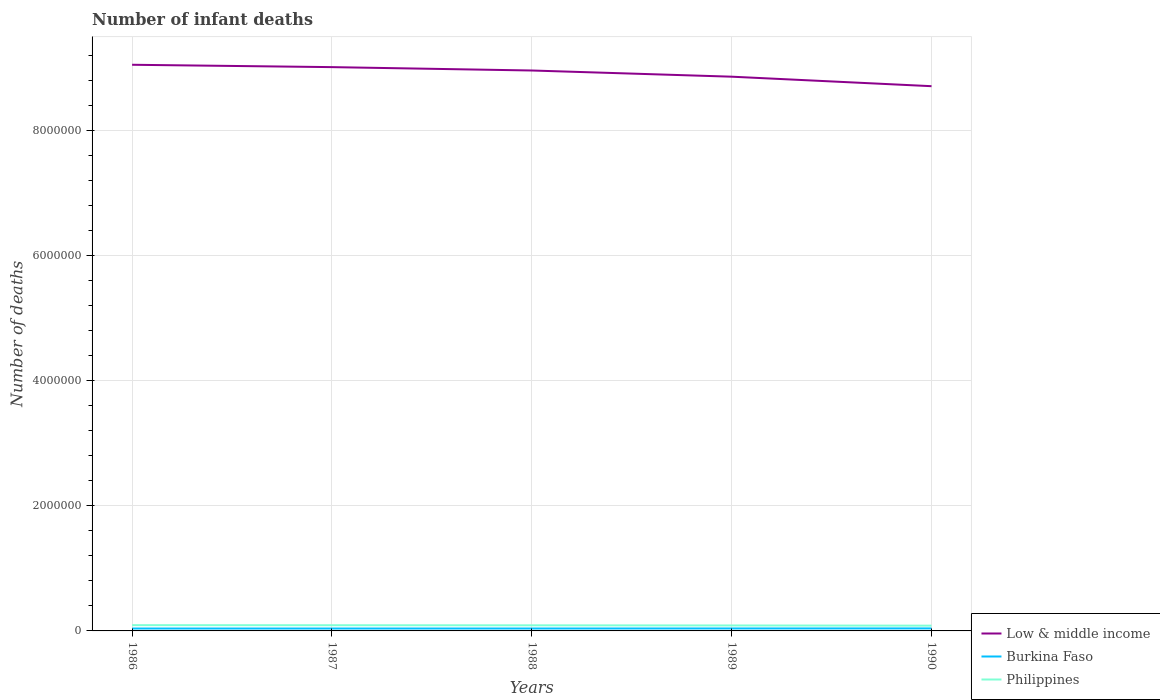How many different coloured lines are there?
Provide a succinct answer. 3. Across all years, what is the maximum number of infant deaths in Burkina Faso?
Make the answer very short. 3.85e+04. What is the total number of infant deaths in Low & middle income in the graph?
Provide a short and direct response. 3.42e+05. What is the difference between the highest and the second highest number of infant deaths in Burkina Faso?
Give a very brief answer. 1697. How many lines are there?
Provide a succinct answer. 3. What is the difference between two consecutive major ticks on the Y-axis?
Your answer should be very brief. 2.00e+06. How many legend labels are there?
Offer a terse response. 3. What is the title of the graph?
Offer a terse response. Number of infant deaths. What is the label or title of the Y-axis?
Your answer should be compact. Number of deaths. What is the Number of deaths in Low & middle income in 1986?
Make the answer very short. 9.05e+06. What is the Number of deaths in Burkina Faso in 1986?
Your response must be concise. 3.85e+04. What is the Number of deaths of Philippines in 1986?
Give a very brief answer. 9.21e+04. What is the Number of deaths in Low & middle income in 1987?
Provide a succinct answer. 9.01e+06. What is the Number of deaths of Burkina Faso in 1987?
Keep it short and to the point. 3.86e+04. What is the Number of deaths of Philippines in 1987?
Offer a terse response. 9.10e+04. What is the Number of deaths in Low & middle income in 1988?
Your response must be concise. 8.96e+06. What is the Number of deaths in Burkina Faso in 1988?
Offer a very short reply. 3.88e+04. What is the Number of deaths in Philippines in 1988?
Offer a very short reply. 8.93e+04. What is the Number of deaths of Low & middle income in 1989?
Your response must be concise. 8.86e+06. What is the Number of deaths in Burkina Faso in 1989?
Provide a short and direct response. 3.93e+04. What is the Number of deaths in Philippines in 1989?
Your response must be concise. 8.70e+04. What is the Number of deaths in Low & middle income in 1990?
Give a very brief answer. 8.71e+06. What is the Number of deaths in Burkina Faso in 1990?
Keep it short and to the point. 4.02e+04. What is the Number of deaths in Philippines in 1990?
Your answer should be compact. 8.41e+04. Across all years, what is the maximum Number of deaths of Low & middle income?
Offer a terse response. 9.05e+06. Across all years, what is the maximum Number of deaths in Burkina Faso?
Offer a very short reply. 4.02e+04. Across all years, what is the maximum Number of deaths in Philippines?
Your response must be concise. 9.21e+04. Across all years, what is the minimum Number of deaths of Low & middle income?
Provide a succinct answer. 8.71e+06. Across all years, what is the minimum Number of deaths in Burkina Faso?
Keep it short and to the point. 3.85e+04. Across all years, what is the minimum Number of deaths of Philippines?
Give a very brief answer. 8.41e+04. What is the total Number of deaths in Low & middle income in the graph?
Your response must be concise. 4.46e+07. What is the total Number of deaths of Burkina Faso in the graph?
Provide a short and direct response. 1.95e+05. What is the total Number of deaths in Philippines in the graph?
Offer a very short reply. 4.44e+05. What is the difference between the Number of deaths in Low & middle income in 1986 and that in 1987?
Offer a very short reply. 3.79e+04. What is the difference between the Number of deaths of Burkina Faso in 1986 and that in 1987?
Make the answer very short. -58. What is the difference between the Number of deaths in Philippines in 1986 and that in 1987?
Your answer should be compact. 1083. What is the difference between the Number of deaths of Low & middle income in 1986 and that in 1988?
Your answer should be very brief. 9.18e+04. What is the difference between the Number of deaths of Burkina Faso in 1986 and that in 1988?
Provide a succinct answer. -287. What is the difference between the Number of deaths of Philippines in 1986 and that in 1988?
Provide a short and direct response. 2729. What is the difference between the Number of deaths in Low & middle income in 1986 and that in 1989?
Make the answer very short. 1.91e+05. What is the difference between the Number of deaths in Burkina Faso in 1986 and that in 1989?
Give a very brief answer. -838. What is the difference between the Number of deaths of Philippines in 1986 and that in 1989?
Offer a terse response. 5028. What is the difference between the Number of deaths of Low & middle income in 1986 and that in 1990?
Provide a short and direct response. 3.42e+05. What is the difference between the Number of deaths of Burkina Faso in 1986 and that in 1990?
Give a very brief answer. -1697. What is the difference between the Number of deaths of Philippines in 1986 and that in 1990?
Ensure brevity in your answer.  7913. What is the difference between the Number of deaths of Low & middle income in 1987 and that in 1988?
Make the answer very short. 5.39e+04. What is the difference between the Number of deaths of Burkina Faso in 1987 and that in 1988?
Offer a very short reply. -229. What is the difference between the Number of deaths in Philippines in 1987 and that in 1988?
Provide a succinct answer. 1646. What is the difference between the Number of deaths in Low & middle income in 1987 and that in 1989?
Your answer should be very brief. 1.53e+05. What is the difference between the Number of deaths in Burkina Faso in 1987 and that in 1989?
Offer a very short reply. -780. What is the difference between the Number of deaths of Philippines in 1987 and that in 1989?
Your response must be concise. 3945. What is the difference between the Number of deaths of Low & middle income in 1987 and that in 1990?
Your answer should be very brief. 3.04e+05. What is the difference between the Number of deaths in Burkina Faso in 1987 and that in 1990?
Provide a succinct answer. -1639. What is the difference between the Number of deaths of Philippines in 1987 and that in 1990?
Ensure brevity in your answer.  6830. What is the difference between the Number of deaths of Low & middle income in 1988 and that in 1989?
Provide a succinct answer. 9.88e+04. What is the difference between the Number of deaths in Burkina Faso in 1988 and that in 1989?
Your response must be concise. -551. What is the difference between the Number of deaths in Philippines in 1988 and that in 1989?
Offer a very short reply. 2299. What is the difference between the Number of deaths of Low & middle income in 1988 and that in 1990?
Your answer should be compact. 2.51e+05. What is the difference between the Number of deaths in Burkina Faso in 1988 and that in 1990?
Provide a short and direct response. -1410. What is the difference between the Number of deaths in Philippines in 1988 and that in 1990?
Offer a very short reply. 5184. What is the difference between the Number of deaths of Low & middle income in 1989 and that in 1990?
Keep it short and to the point. 1.52e+05. What is the difference between the Number of deaths of Burkina Faso in 1989 and that in 1990?
Make the answer very short. -859. What is the difference between the Number of deaths of Philippines in 1989 and that in 1990?
Keep it short and to the point. 2885. What is the difference between the Number of deaths of Low & middle income in 1986 and the Number of deaths of Burkina Faso in 1987?
Your answer should be compact. 9.01e+06. What is the difference between the Number of deaths in Low & middle income in 1986 and the Number of deaths in Philippines in 1987?
Provide a short and direct response. 8.96e+06. What is the difference between the Number of deaths in Burkina Faso in 1986 and the Number of deaths in Philippines in 1987?
Ensure brevity in your answer.  -5.25e+04. What is the difference between the Number of deaths of Low & middle income in 1986 and the Number of deaths of Burkina Faso in 1988?
Your response must be concise. 9.01e+06. What is the difference between the Number of deaths of Low & middle income in 1986 and the Number of deaths of Philippines in 1988?
Provide a succinct answer. 8.96e+06. What is the difference between the Number of deaths in Burkina Faso in 1986 and the Number of deaths in Philippines in 1988?
Provide a succinct answer. -5.08e+04. What is the difference between the Number of deaths of Low & middle income in 1986 and the Number of deaths of Burkina Faso in 1989?
Make the answer very short. 9.01e+06. What is the difference between the Number of deaths of Low & middle income in 1986 and the Number of deaths of Philippines in 1989?
Make the answer very short. 8.96e+06. What is the difference between the Number of deaths of Burkina Faso in 1986 and the Number of deaths of Philippines in 1989?
Give a very brief answer. -4.85e+04. What is the difference between the Number of deaths of Low & middle income in 1986 and the Number of deaths of Burkina Faso in 1990?
Provide a short and direct response. 9.01e+06. What is the difference between the Number of deaths in Low & middle income in 1986 and the Number of deaths in Philippines in 1990?
Provide a succinct answer. 8.96e+06. What is the difference between the Number of deaths in Burkina Faso in 1986 and the Number of deaths in Philippines in 1990?
Offer a terse response. -4.56e+04. What is the difference between the Number of deaths in Low & middle income in 1987 and the Number of deaths in Burkina Faso in 1988?
Your answer should be compact. 8.97e+06. What is the difference between the Number of deaths in Low & middle income in 1987 and the Number of deaths in Philippines in 1988?
Your answer should be compact. 8.92e+06. What is the difference between the Number of deaths in Burkina Faso in 1987 and the Number of deaths in Philippines in 1988?
Give a very brief answer. -5.08e+04. What is the difference between the Number of deaths in Low & middle income in 1987 and the Number of deaths in Burkina Faso in 1989?
Your answer should be compact. 8.97e+06. What is the difference between the Number of deaths of Low & middle income in 1987 and the Number of deaths of Philippines in 1989?
Your answer should be very brief. 8.92e+06. What is the difference between the Number of deaths of Burkina Faso in 1987 and the Number of deaths of Philippines in 1989?
Provide a succinct answer. -4.85e+04. What is the difference between the Number of deaths of Low & middle income in 1987 and the Number of deaths of Burkina Faso in 1990?
Your answer should be very brief. 8.97e+06. What is the difference between the Number of deaths of Low & middle income in 1987 and the Number of deaths of Philippines in 1990?
Offer a very short reply. 8.93e+06. What is the difference between the Number of deaths in Burkina Faso in 1987 and the Number of deaths in Philippines in 1990?
Offer a terse response. -4.56e+04. What is the difference between the Number of deaths in Low & middle income in 1988 and the Number of deaths in Burkina Faso in 1989?
Keep it short and to the point. 8.92e+06. What is the difference between the Number of deaths of Low & middle income in 1988 and the Number of deaths of Philippines in 1989?
Ensure brevity in your answer.  8.87e+06. What is the difference between the Number of deaths of Burkina Faso in 1988 and the Number of deaths of Philippines in 1989?
Give a very brief answer. -4.82e+04. What is the difference between the Number of deaths in Low & middle income in 1988 and the Number of deaths in Burkina Faso in 1990?
Offer a terse response. 8.92e+06. What is the difference between the Number of deaths in Low & middle income in 1988 and the Number of deaths in Philippines in 1990?
Provide a succinct answer. 8.87e+06. What is the difference between the Number of deaths in Burkina Faso in 1988 and the Number of deaths in Philippines in 1990?
Your response must be concise. -4.53e+04. What is the difference between the Number of deaths in Low & middle income in 1989 and the Number of deaths in Burkina Faso in 1990?
Offer a very short reply. 8.82e+06. What is the difference between the Number of deaths in Low & middle income in 1989 and the Number of deaths in Philippines in 1990?
Offer a very short reply. 8.77e+06. What is the difference between the Number of deaths of Burkina Faso in 1989 and the Number of deaths of Philippines in 1990?
Make the answer very short. -4.48e+04. What is the average Number of deaths in Low & middle income per year?
Your answer should be very brief. 8.92e+06. What is the average Number of deaths in Burkina Faso per year?
Give a very brief answer. 3.91e+04. What is the average Number of deaths of Philippines per year?
Ensure brevity in your answer.  8.87e+04. In the year 1986, what is the difference between the Number of deaths of Low & middle income and Number of deaths of Burkina Faso?
Keep it short and to the point. 9.01e+06. In the year 1986, what is the difference between the Number of deaths of Low & middle income and Number of deaths of Philippines?
Give a very brief answer. 8.96e+06. In the year 1986, what is the difference between the Number of deaths of Burkina Faso and Number of deaths of Philippines?
Your answer should be very brief. -5.35e+04. In the year 1987, what is the difference between the Number of deaths of Low & middle income and Number of deaths of Burkina Faso?
Your answer should be compact. 8.97e+06. In the year 1987, what is the difference between the Number of deaths in Low & middle income and Number of deaths in Philippines?
Your answer should be compact. 8.92e+06. In the year 1987, what is the difference between the Number of deaths in Burkina Faso and Number of deaths in Philippines?
Keep it short and to the point. -5.24e+04. In the year 1988, what is the difference between the Number of deaths of Low & middle income and Number of deaths of Burkina Faso?
Ensure brevity in your answer.  8.92e+06. In the year 1988, what is the difference between the Number of deaths of Low & middle income and Number of deaths of Philippines?
Your answer should be compact. 8.87e+06. In the year 1988, what is the difference between the Number of deaths in Burkina Faso and Number of deaths in Philippines?
Provide a succinct answer. -5.05e+04. In the year 1989, what is the difference between the Number of deaths in Low & middle income and Number of deaths in Burkina Faso?
Ensure brevity in your answer.  8.82e+06. In the year 1989, what is the difference between the Number of deaths in Low & middle income and Number of deaths in Philippines?
Offer a very short reply. 8.77e+06. In the year 1989, what is the difference between the Number of deaths in Burkina Faso and Number of deaths in Philippines?
Your answer should be very brief. -4.77e+04. In the year 1990, what is the difference between the Number of deaths in Low & middle income and Number of deaths in Burkina Faso?
Provide a succinct answer. 8.67e+06. In the year 1990, what is the difference between the Number of deaths in Low & middle income and Number of deaths in Philippines?
Provide a succinct answer. 8.62e+06. In the year 1990, what is the difference between the Number of deaths in Burkina Faso and Number of deaths in Philippines?
Your answer should be very brief. -4.39e+04. What is the ratio of the Number of deaths in Burkina Faso in 1986 to that in 1987?
Offer a very short reply. 1. What is the ratio of the Number of deaths in Philippines in 1986 to that in 1987?
Keep it short and to the point. 1.01. What is the ratio of the Number of deaths of Low & middle income in 1986 to that in 1988?
Offer a terse response. 1.01. What is the ratio of the Number of deaths of Philippines in 1986 to that in 1988?
Keep it short and to the point. 1.03. What is the ratio of the Number of deaths of Low & middle income in 1986 to that in 1989?
Your answer should be very brief. 1.02. What is the ratio of the Number of deaths in Burkina Faso in 1986 to that in 1989?
Your answer should be compact. 0.98. What is the ratio of the Number of deaths of Philippines in 1986 to that in 1989?
Your response must be concise. 1.06. What is the ratio of the Number of deaths of Low & middle income in 1986 to that in 1990?
Your answer should be very brief. 1.04. What is the ratio of the Number of deaths of Burkina Faso in 1986 to that in 1990?
Your response must be concise. 0.96. What is the ratio of the Number of deaths in Philippines in 1986 to that in 1990?
Offer a very short reply. 1.09. What is the ratio of the Number of deaths of Low & middle income in 1987 to that in 1988?
Your answer should be compact. 1.01. What is the ratio of the Number of deaths of Philippines in 1987 to that in 1988?
Your response must be concise. 1.02. What is the ratio of the Number of deaths in Low & middle income in 1987 to that in 1989?
Offer a very short reply. 1.02. What is the ratio of the Number of deaths of Burkina Faso in 1987 to that in 1989?
Offer a very short reply. 0.98. What is the ratio of the Number of deaths in Philippines in 1987 to that in 1989?
Make the answer very short. 1.05. What is the ratio of the Number of deaths of Low & middle income in 1987 to that in 1990?
Give a very brief answer. 1.03. What is the ratio of the Number of deaths in Burkina Faso in 1987 to that in 1990?
Keep it short and to the point. 0.96. What is the ratio of the Number of deaths in Philippines in 1987 to that in 1990?
Provide a short and direct response. 1.08. What is the ratio of the Number of deaths in Low & middle income in 1988 to that in 1989?
Provide a short and direct response. 1.01. What is the ratio of the Number of deaths of Philippines in 1988 to that in 1989?
Ensure brevity in your answer.  1.03. What is the ratio of the Number of deaths in Low & middle income in 1988 to that in 1990?
Keep it short and to the point. 1.03. What is the ratio of the Number of deaths in Burkina Faso in 1988 to that in 1990?
Your answer should be very brief. 0.96. What is the ratio of the Number of deaths of Philippines in 1988 to that in 1990?
Offer a very short reply. 1.06. What is the ratio of the Number of deaths of Low & middle income in 1989 to that in 1990?
Keep it short and to the point. 1.02. What is the ratio of the Number of deaths of Burkina Faso in 1989 to that in 1990?
Your answer should be very brief. 0.98. What is the ratio of the Number of deaths of Philippines in 1989 to that in 1990?
Offer a very short reply. 1.03. What is the difference between the highest and the second highest Number of deaths of Low & middle income?
Provide a succinct answer. 3.79e+04. What is the difference between the highest and the second highest Number of deaths of Burkina Faso?
Your answer should be very brief. 859. What is the difference between the highest and the second highest Number of deaths of Philippines?
Your response must be concise. 1083. What is the difference between the highest and the lowest Number of deaths of Low & middle income?
Your answer should be very brief. 3.42e+05. What is the difference between the highest and the lowest Number of deaths of Burkina Faso?
Your response must be concise. 1697. What is the difference between the highest and the lowest Number of deaths of Philippines?
Provide a short and direct response. 7913. 